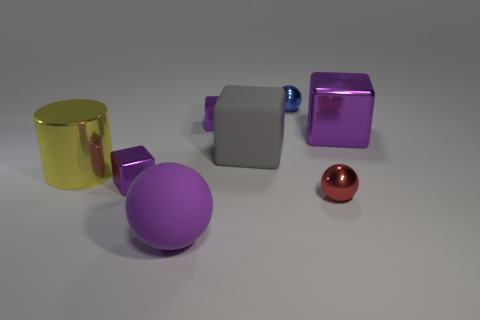There is a gray thing behind the matte object that is in front of the rubber cube; how big is it?
Your answer should be compact. Large. How many small things are green shiny balls or red shiny objects?
Provide a short and direct response. 1. Is the number of blue shiny balls less than the number of large purple metal spheres?
Give a very brief answer. No. Is the large rubber sphere the same color as the large shiny block?
Ensure brevity in your answer.  Yes. Is the number of gray metallic blocks greater than the number of objects?
Your answer should be very brief. No. What number of other things are there of the same color as the large matte ball?
Ensure brevity in your answer.  3. There is a large rubber thing that is behind the purple matte ball; what number of balls are left of it?
Offer a terse response. 1. There is a purple matte object; are there any large rubber spheres behind it?
Your answer should be compact. No. What is the shape of the large rubber thing that is to the right of the big matte thing that is in front of the yellow thing?
Your response must be concise. Cube. Is the number of red shiny things on the left side of the red metal sphere less than the number of purple shiny blocks in front of the big gray rubber cube?
Offer a terse response. Yes. 